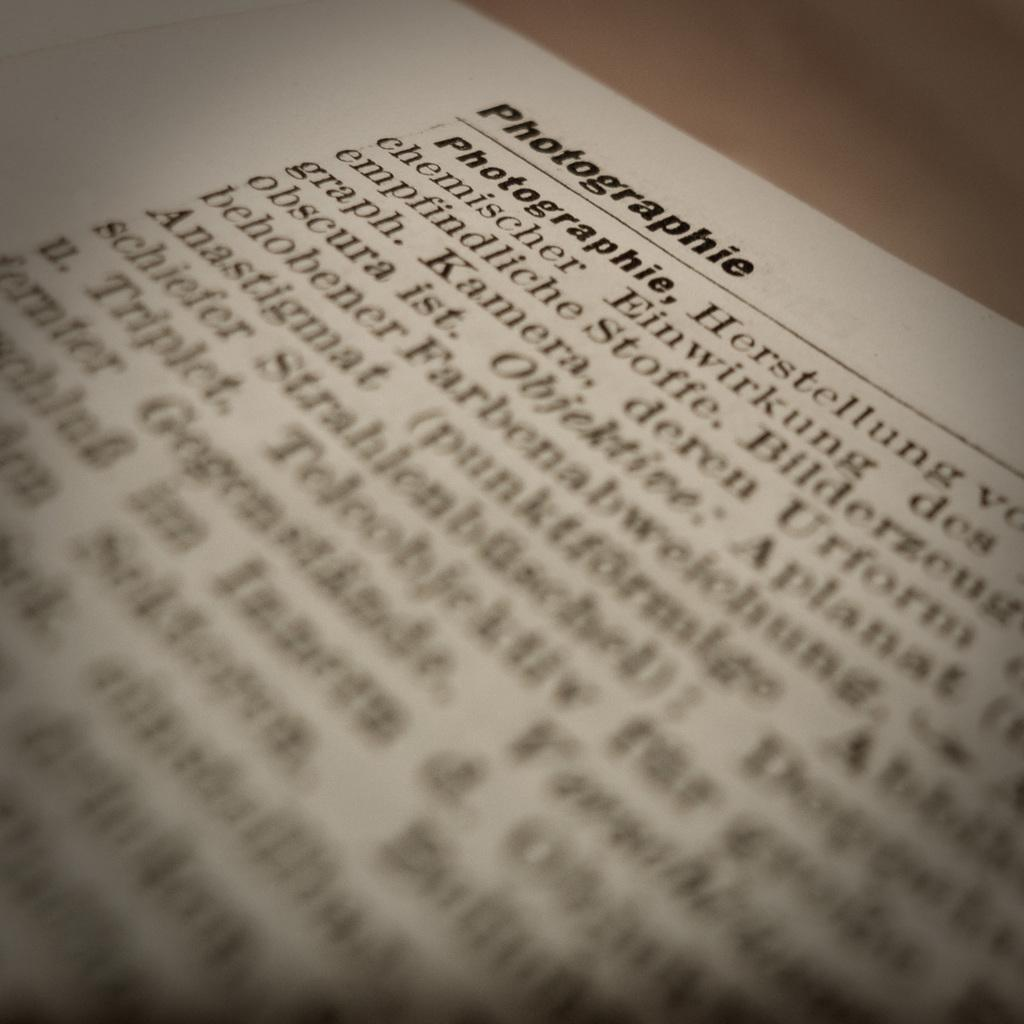What is written on in the image? There is text on a white color paper in the image. What is the color of the table the paper is on? The paper is on a brown color table in the image. What type of machine can be seen operating in the harbor in the image? There is no machine or harbor present in the image; it only features text on a white paper on a brown table. What color is the pen used to write the text on the paper in the image? There is no pen visible in the image, and the color of the pen used to write the text cannot be determined. 